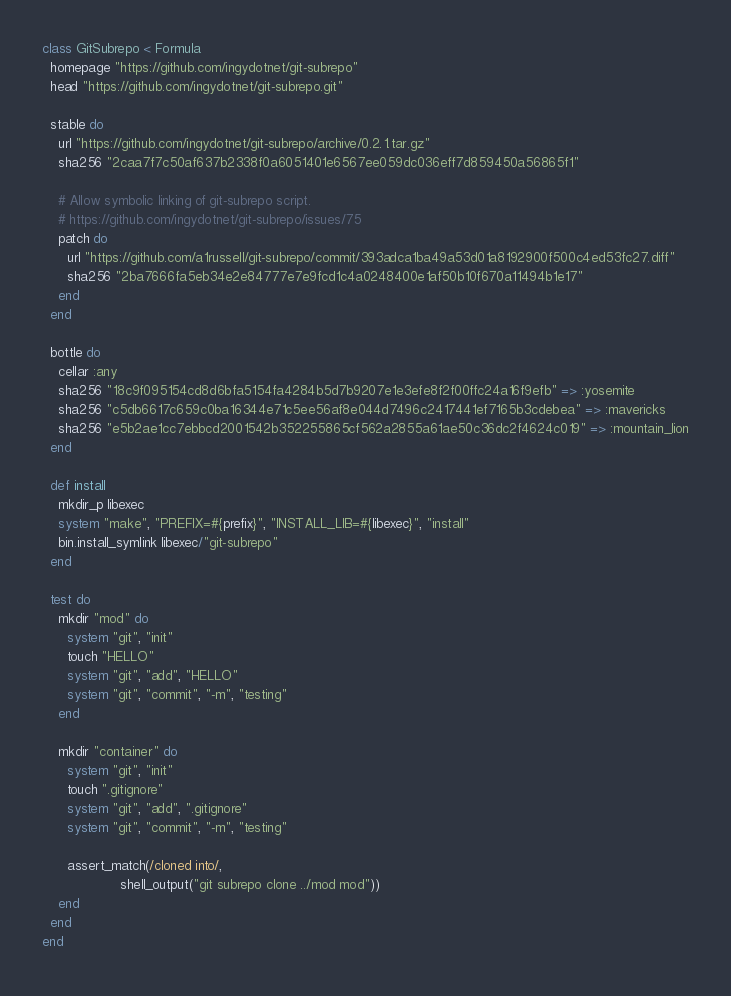<code> <loc_0><loc_0><loc_500><loc_500><_Ruby_>class GitSubrepo < Formula
  homepage "https://github.com/ingydotnet/git-subrepo"
  head "https://github.com/ingydotnet/git-subrepo.git"

  stable do
    url "https://github.com/ingydotnet/git-subrepo/archive/0.2.1.tar.gz"
    sha256 "2caa7f7c50af637b2338f0a6051401e6567ee059dc036eff7d859450a56865f1"

    # Allow symbolic linking of git-subrepo script.
    # https://github.com/ingydotnet/git-subrepo/issues/75
    patch do
      url "https://github.com/a1russell/git-subrepo/commit/393adca1ba49a53d01a8192900f500c4ed53fc27.diff"
      sha256 "2ba7666fa5eb34e2e84777e7e9fcd1c4a0248400e1af50b10f670a11494b1e17"
    end
  end

  bottle do
    cellar :any
    sha256 "18c9f095154cd8d6bfa5154fa4284b5d7b9207e1e3efe8f2f00ffc24a16f9efb" => :yosemite
    sha256 "c5db6617c659c0ba16344e71c5ee56af8e044d7496c2417441ef7165b3cdebea" => :mavericks
    sha256 "e5b2ae1cc7ebbcd2001542b352255865cf562a2855a61ae50c36dc2f4624c019" => :mountain_lion
  end

  def install
    mkdir_p libexec
    system "make", "PREFIX=#{prefix}", "INSTALL_LIB=#{libexec}", "install"
    bin.install_symlink libexec/"git-subrepo"
  end

  test do
    mkdir "mod" do
      system "git", "init"
      touch "HELLO"
      system "git", "add", "HELLO"
      system "git", "commit", "-m", "testing"
    end

    mkdir "container" do
      system "git", "init"
      touch ".gitignore"
      system "git", "add", ".gitignore"
      system "git", "commit", "-m", "testing"

      assert_match(/cloned into/,
                   shell_output("git subrepo clone ../mod mod"))
    end
  end
end
</code> 